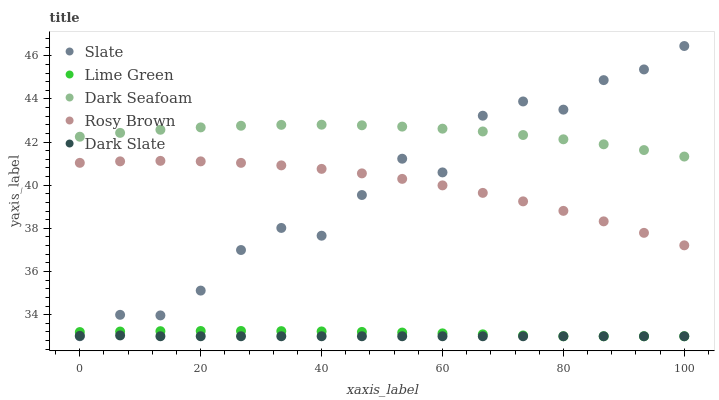Does Dark Slate have the minimum area under the curve?
Answer yes or no. Yes. Does Dark Seafoam have the maximum area under the curve?
Answer yes or no. Yes. Does Slate have the minimum area under the curve?
Answer yes or no. No. Does Slate have the maximum area under the curve?
Answer yes or no. No. Is Dark Slate the smoothest?
Answer yes or no. Yes. Is Slate the roughest?
Answer yes or no. Yes. Is Rosy Brown the smoothest?
Answer yes or no. No. Is Rosy Brown the roughest?
Answer yes or no. No. Does Dark Slate have the lowest value?
Answer yes or no. Yes. Does Rosy Brown have the lowest value?
Answer yes or no. No. Does Slate have the highest value?
Answer yes or no. Yes. Does Rosy Brown have the highest value?
Answer yes or no. No. Is Dark Slate less than Rosy Brown?
Answer yes or no. Yes. Is Dark Seafoam greater than Dark Slate?
Answer yes or no. Yes. Does Dark Seafoam intersect Slate?
Answer yes or no. Yes. Is Dark Seafoam less than Slate?
Answer yes or no. No. Is Dark Seafoam greater than Slate?
Answer yes or no. No. Does Dark Slate intersect Rosy Brown?
Answer yes or no. No. 